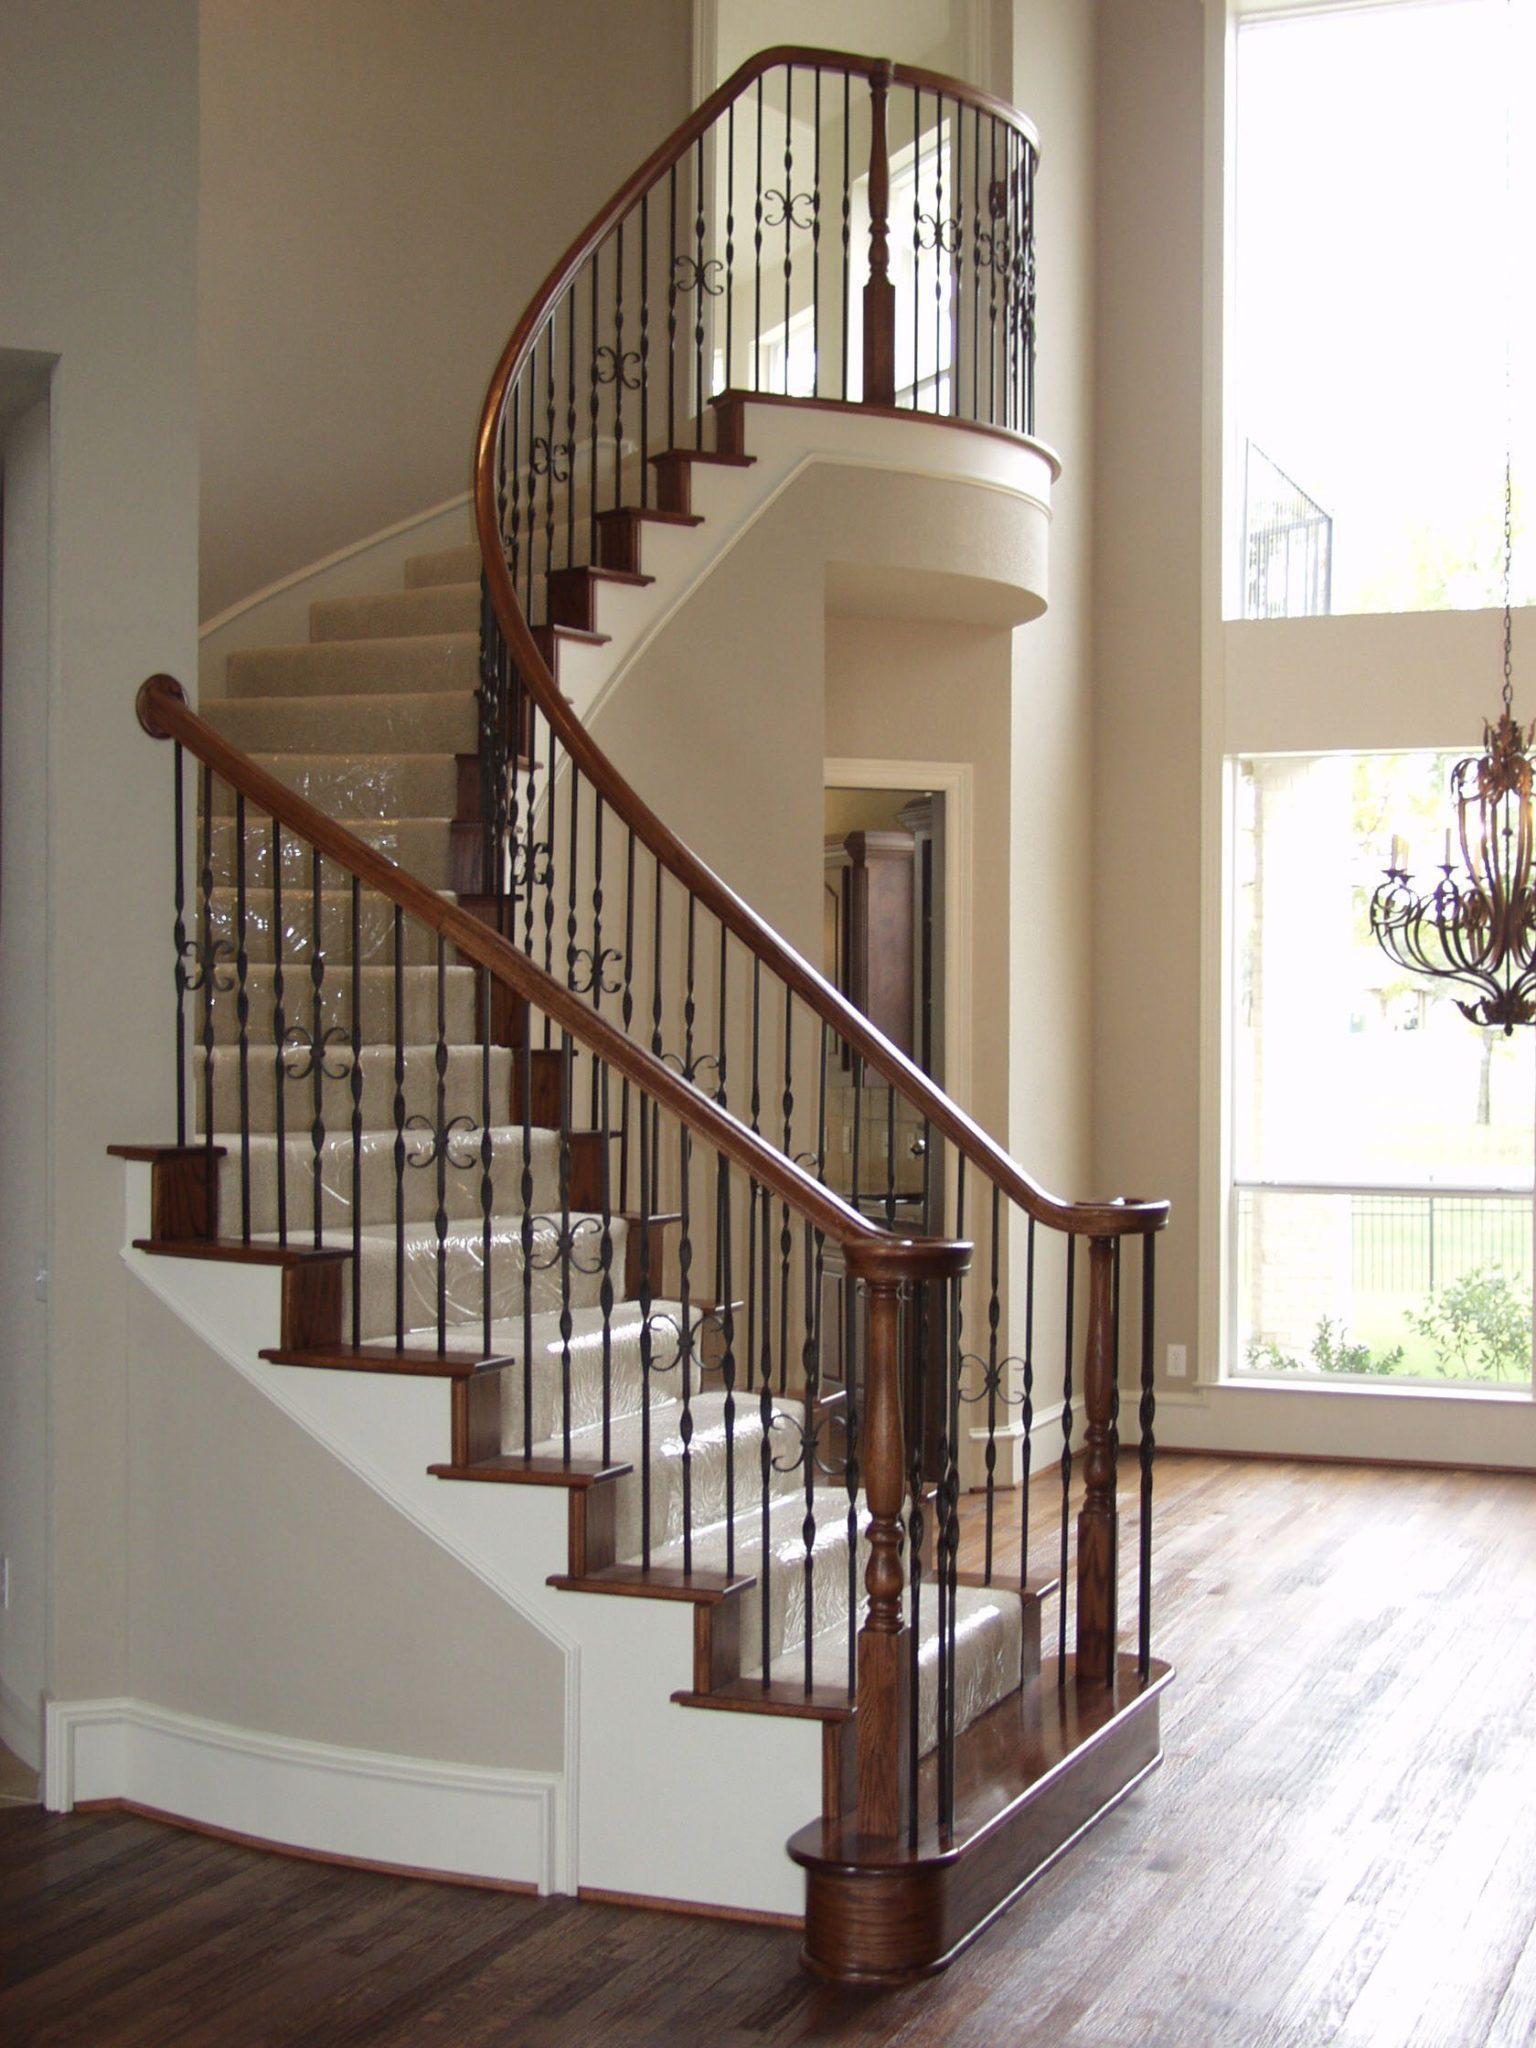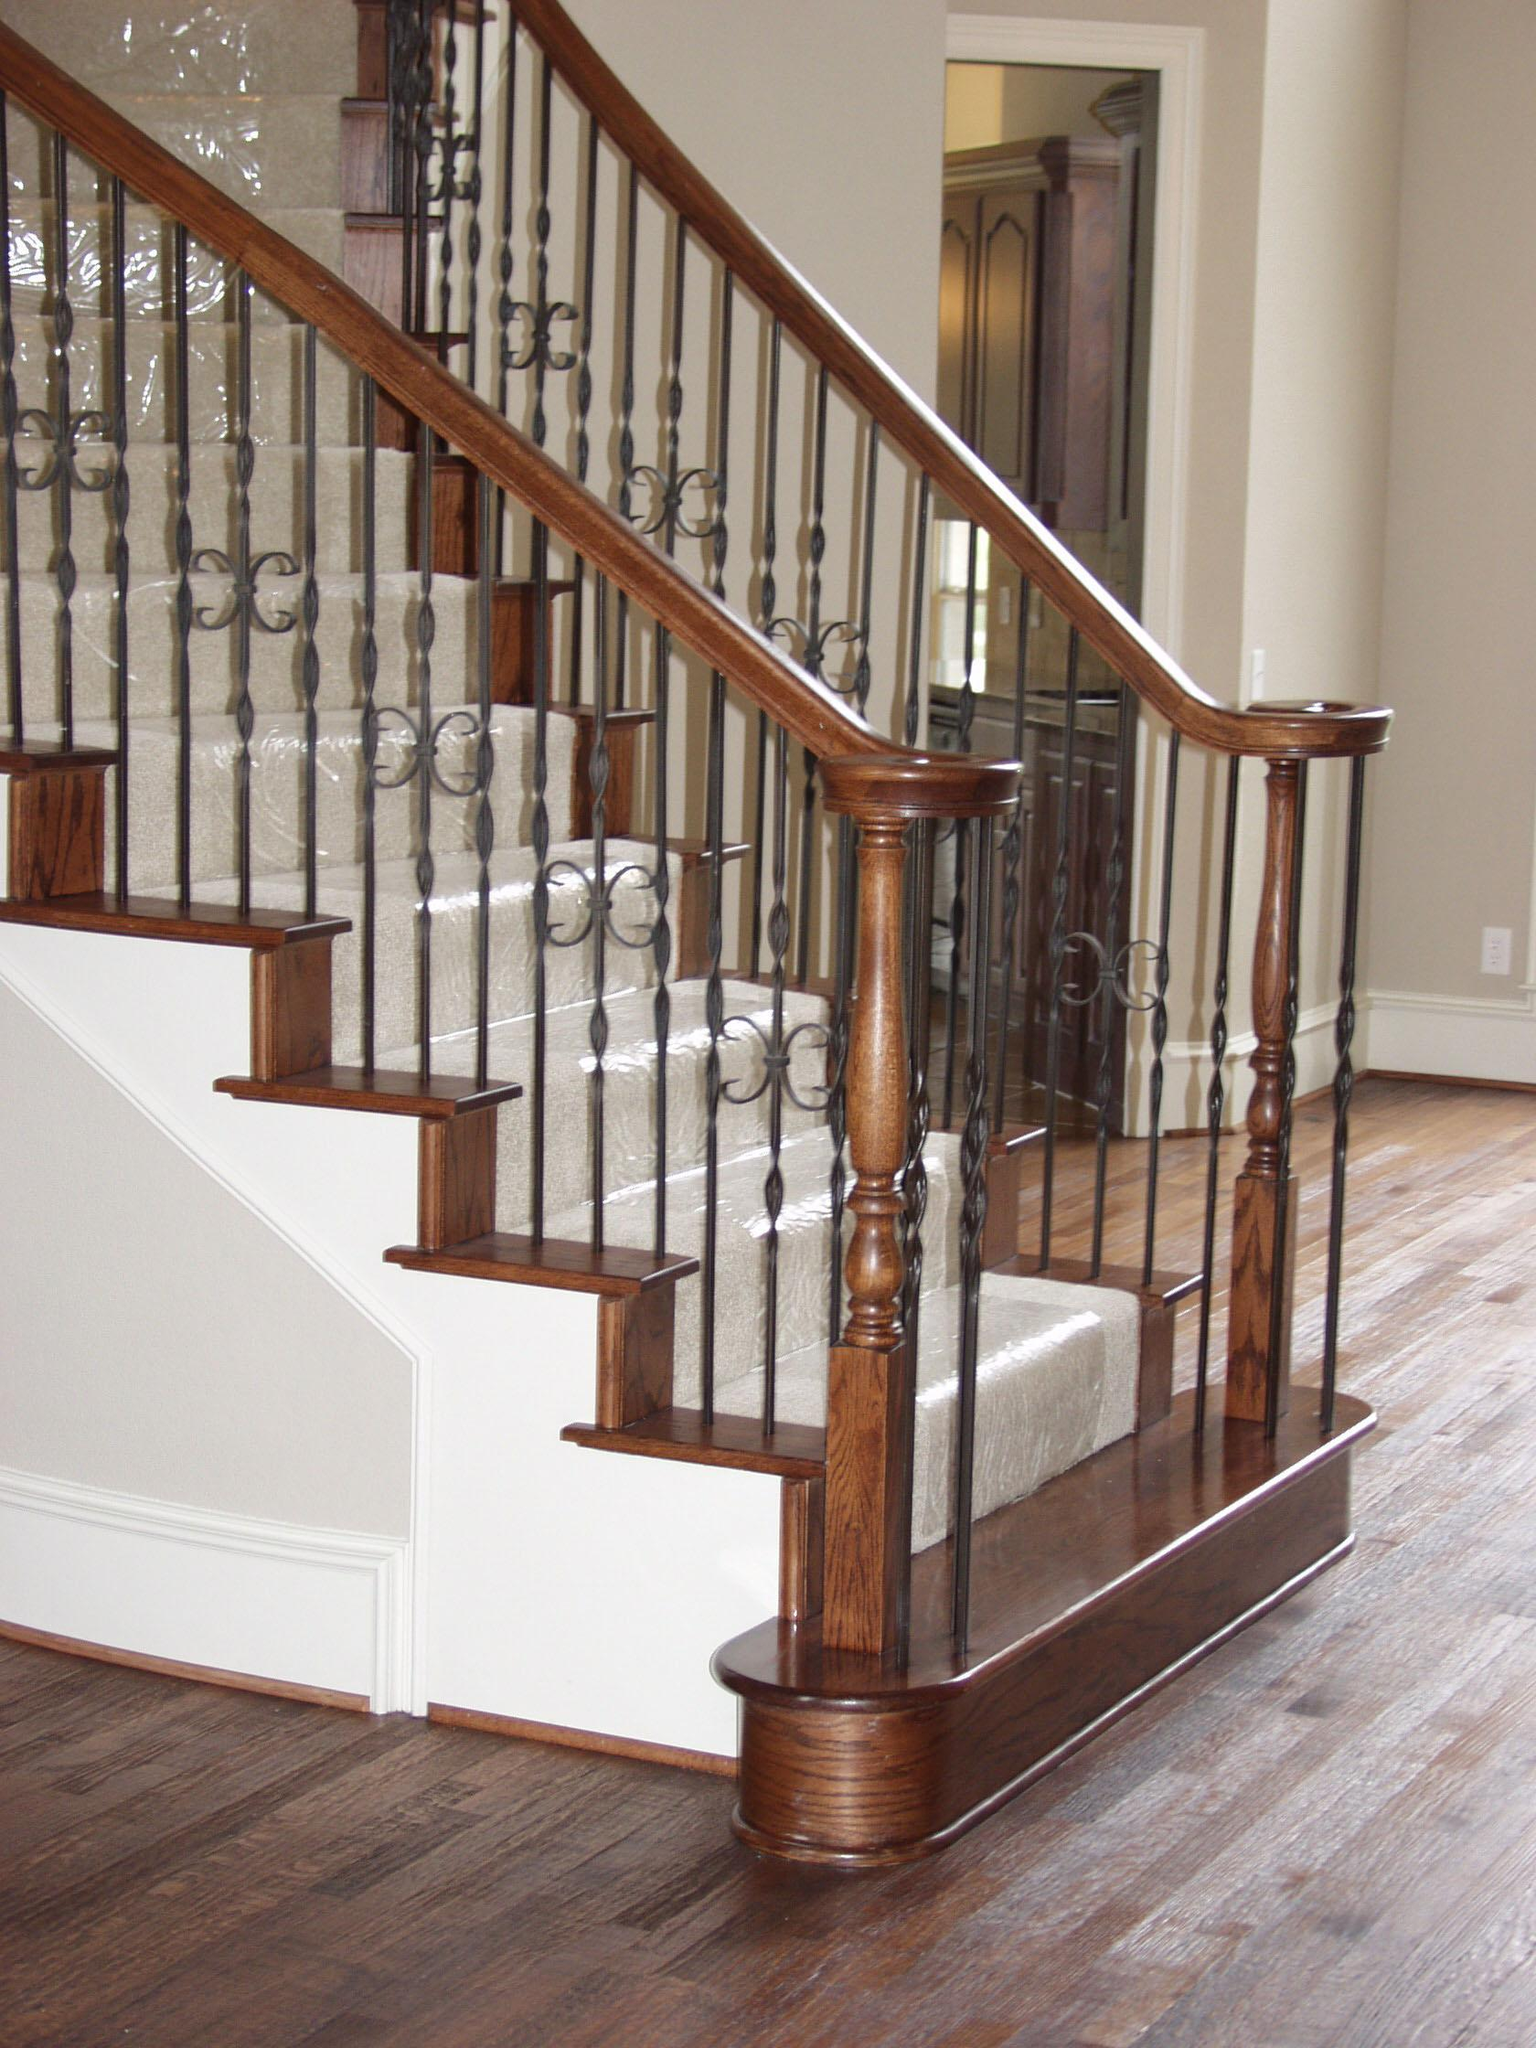The first image is the image on the left, the second image is the image on the right. For the images shown, is this caption "The left staircase is straight and the right staircase is curved." true? Answer yes or no. No. 